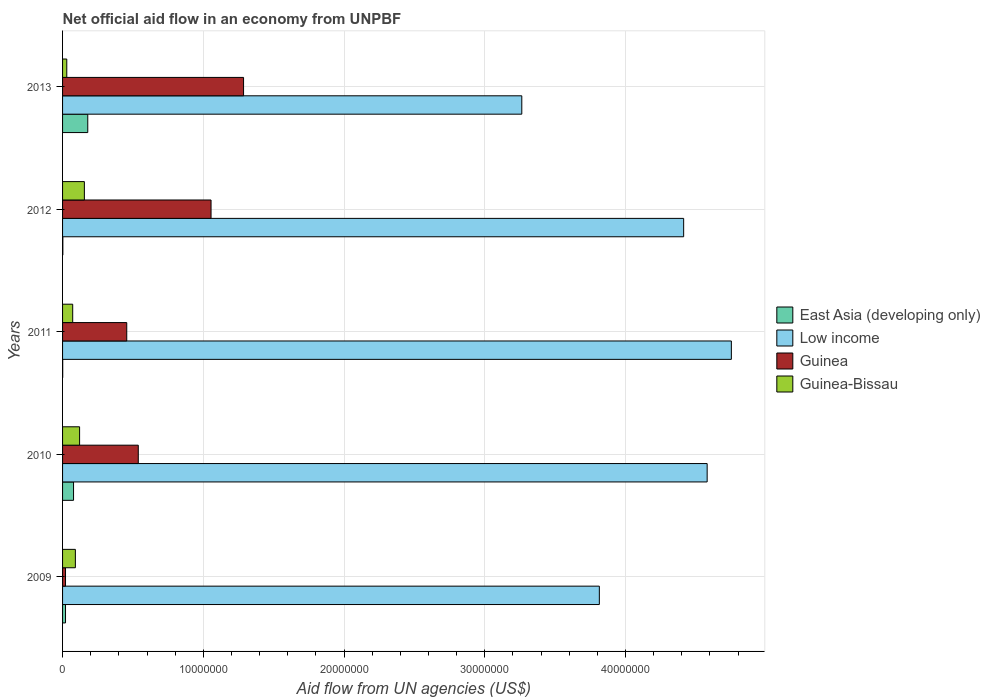How many bars are there on the 1st tick from the top?
Offer a terse response. 4. In how many cases, is the number of bars for a given year not equal to the number of legend labels?
Give a very brief answer. 0. What is the net official aid flow in East Asia (developing only) in 2010?
Offer a terse response. 7.80e+05. Across all years, what is the maximum net official aid flow in Low income?
Offer a terse response. 4.75e+07. Across all years, what is the minimum net official aid flow in Low income?
Offer a very short reply. 3.26e+07. In which year was the net official aid flow in Guinea minimum?
Your answer should be very brief. 2009. What is the total net official aid flow in East Asia (developing only) in the graph?
Offer a very short reply. 2.81e+06. What is the difference between the net official aid flow in Guinea-Bissau in 2011 and that in 2012?
Offer a very short reply. -8.30e+05. What is the difference between the net official aid flow in Low income in 2013 and the net official aid flow in Guinea-Bissau in 2012?
Give a very brief answer. 3.11e+07. What is the average net official aid flow in East Asia (developing only) per year?
Offer a very short reply. 5.62e+05. In the year 2012, what is the difference between the net official aid flow in East Asia (developing only) and net official aid flow in Guinea-Bissau?
Keep it short and to the point. -1.53e+06. In how many years, is the net official aid flow in Guinea-Bissau greater than 28000000 US$?
Your answer should be compact. 0. What is the ratio of the net official aid flow in East Asia (developing only) in 2012 to that in 2013?
Provide a succinct answer. 0.01. Is the net official aid flow in East Asia (developing only) in 2009 less than that in 2011?
Your answer should be compact. No. What is the difference between the highest and the second highest net official aid flow in Low income?
Give a very brief answer. 1.72e+06. What is the difference between the highest and the lowest net official aid flow in Guinea?
Offer a very short reply. 1.26e+07. What does the 4th bar from the top in 2013 represents?
Provide a succinct answer. East Asia (developing only). Are all the bars in the graph horizontal?
Your answer should be compact. Yes. How many years are there in the graph?
Offer a very short reply. 5. What is the difference between two consecutive major ticks on the X-axis?
Your answer should be very brief. 1.00e+07. How many legend labels are there?
Keep it short and to the point. 4. How are the legend labels stacked?
Offer a terse response. Vertical. What is the title of the graph?
Offer a very short reply. Net official aid flow in an economy from UNPBF. Does "Aruba" appear as one of the legend labels in the graph?
Offer a very short reply. No. What is the label or title of the X-axis?
Your response must be concise. Aid flow from UN agencies (US$). What is the label or title of the Y-axis?
Your answer should be compact. Years. What is the Aid flow from UN agencies (US$) in Low income in 2009?
Your response must be concise. 3.81e+07. What is the Aid flow from UN agencies (US$) of Guinea-Bissau in 2009?
Provide a short and direct response. 9.10e+05. What is the Aid flow from UN agencies (US$) of East Asia (developing only) in 2010?
Offer a very short reply. 7.80e+05. What is the Aid flow from UN agencies (US$) in Low income in 2010?
Provide a short and direct response. 4.58e+07. What is the Aid flow from UN agencies (US$) of Guinea in 2010?
Make the answer very short. 5.38e+06. What is the Aid flow from UN agencies (US$) of Guinea-Bissau in 2010?
Provide a short and direct response. 1.21e+06. What is the Aid flow from UN agencies (US$) of East Asia (developing only) in 2011?
Provide a short and direct response. 10000. What is the Aid flow from UN agencies (US$) of Low income in 2011?
Offer a terse response. 4.75e+07. What is the Aid flow from UN agencies (US$) in Guinea in 2011?
Keep it short and to the point. 4.56e+06. What is the Aid flow from UN agencies (US$) of Guinea-Bissau in 2011?
Provide a succinct answer. 7.20e+05. What is the Aid flow from UN agencies (US$) of East Asia (developing only) in 2012?
Your answer should be very brief. 2.00e+04. What is the Aid flow from UN agencies (US$) in Low income in 2012?
Provide a short and direct response. 4.41e+07. What is the Aid flow from UN agencies (US$) of Guinea in 2012?
Your answer should be compact. 1.06e+07. What is the Aid flow from UN agencies (US$) of Guinea-Bissau in 2012?
Make the answer very short. 1.55e+06. What is the Aid flow from UN agencies (US$) in East Asia (developing only) in 2013?
Provide a short and direct response. 1.79e+06. What is the Aid flow from UN agencies (US$) in Low income in 2013?
Provide a succinct answer. 3.26e+07. What is the Aid flow from UN agencies (US$) of Guinea in 2013?
Your answer should be compact. 1.29e+07. Across all years, what is the maximum Aid flow from UN agencies (US$) in East Asia (developing only)?
Your response must be concise. 1.79e+06. Across all years, what is the maximum Aid flow from UN agencies (US$) of Low income?
Your response must be concise. 4.75e+07. Across all years, what is the maximum Aid flow from UN agencies (US$) in Guinea?
Offer a terse response. 1.29e+07. Across all years, what is the maximum Aid flow from UN agencies (US$) in Guinea-Bissau?
Provide a short and direct response. 1.55e+06. Across all years, what is the minimum Aid flow from UN agencies (US$) of East Asia (developing only)?
Offer a very short reply. 10000. Across all years, what is the minimum Aid flow from UN agencies (US$) of Low income?
Offer a very short reply. 3.26e+07. Across all years, what is the minimum Aid flow from UN agencies (US$) in Guinea?
Keep it short and to the point. 2.10e+05. What is the total Aid flow from UN agencies (US$) in East Asia (developing only) in the graph?
Your response must be concise. 2.81e+06. What is the total Aid flow from UN agencies (US$) of Low income in the graph?
Your answer should be very brief. 2.08e+08. What is the total Aid flow from UN agencies (US$) in Guinea in the graph?
Your response must be concise. 3.36e+07. What is the total Aid flow from UN agencies (US$) in Guinea-Bissau in the graph?
Your answer should be compact. 4.69e+06. What is the difference between the Aid flow from UN agencies (US$) of East Asia (developing only) in 2009 and that in 2010?
Keep it short and to the point. -5.70e+05. What is the difference between the Aid flow from UN agencies (US$) in Low income in 2009 and that in 2010?
Your response must be concise. -7.66e+06. What is the difference between the Aid flow from UN agencies (US$) in Guinea in 2009 and that in 2010?
Your answer should be very brief. -5.17e+06. What is the difference between the Aid flow from UN agencies (US$) of Low income in 2009 and that in 2011?
Offer a very short reply. -9.38e+06. What is the difference between the Aid flow from UN agencies (US$) of Guinea in 2009 and that in 2011?
Give a very brief answer. -4.35e+06. What is the difference between the Aid flow from UN agencies (US$) of Guinea-Bissau in 2009 and that in 2011?
Offer a very short reply. 1.90e+05. What is the difference between the Aid flow from UN agencies (US$) in Low income in 2009 and that in 2012?
Offer a terse response. -5.99e+06. What is the difference between the Aid flow from UN agencies (US$) in Guinea in 2009 and that in 2012?
Make the answer very short. -1.03e+07. What is the difference between the Aid flow from UN agencies (US$) of Guinea-Bissau in 2009 and that in 2012?
Ensure brevity in your answer.  -6.40e+05. What is the difference between the Aid flow from UN agencies (US$) in East Asia (developing only) in 2009 and that in 2013?
Your answer should be compact. -1.58e+06. What is the difference between the Aid flow from UN agencies (US$) in Low income in 2009 and that in 2013?
Offer a very short reply. 5.51e+06. What is the difference between the Aid flow from UN agencies (US$) in Guinea in 2009 and that in 2013?
Keep it short and to the point. -1.26e+07. What is the difference between the Aid flow from UN agencies (US$) in Guinea-Bissau in 2009 and that in 2013?
Your response must be concise. 6.10e+05. What is the difference between the Aid flow from UN agencies (US$) in East Asia (developing only) in 2010 and that in 2011?
Your answer should be compact. 7.70e+05. What is the difference between the Aid flow from UN agencies (US$) of Low income in 2010 and that in 2011?
Give a very brief answer. -1.72e+06. What is the difference between the Aid flow from UN agencies (US$) of Guinea in 2010 and that in 2011?
Give a very brief answer. 8.20e+05. What is the difference between the Aid flow from UN agencies (US$) in Guinea-Bissau in 2010 and that in 2011?
Give a very brief answer. 4.90e+05. What is the difference between the Aid flow from UN agencies (US$) in East Asia (developing only) in 2010 and that in 2012?
Your response must be concise. 7.60e+05. What is the difference between the Aid flow from UN agencies (US$) in Low income in 2010 and that in 2012?
Your answer should be compact. 1.67e+06. What is the difference between the Aid flow from UN agencies (US$) of Guinea in 2010 and that in 2012?
Give a very brief answer. -5.17e+06. What is the difference between the Aid flow from UN agencies (US$) of Guinea-Bissau in 2010 and that in 2012?
Provide a short and direct response. -3.40e+05. What is the difference between the Aid flow from UN agencies (US$) of East Asia (developing only) in 2010 and that in 2013?
Make the answer very short. -1.01e+06. What is the difference between the Aid flow from UN agencies (US$) of Low income in 2010 and that in 2013?
Keep it short and to the point. 1.32e+07. What is the difference between the Aid flow from UN agencies (US$) in Guinea in 2010 and that in 2013?
Provide a short and direct response. -7.48e+06. What is the difference between the Aid flow from UN agencies (US$) in Guinea-Bissau in 2010 and that in 2013?
Give a very brief answer. 9.10e+05. What is the difference between the Aid flow from UN agencies (US$) of Low income in 2011 and that in 2012?
Your answer should be compact. 3.39e+06. What is the difference between the Aid flow from UN agencies (US$) in Guinea in 2011 and that in 2012?
Keep it short and to the point. -5.99e+06. What is the difference between the Aid flow from UN agencies (US$) in Guinea-Bissau in 2011 and that in 2012?
Your response must be concise. -8.30e+05. What is the difference between the Aid flow from UN agencies (US$) of East Asia (developing only) in 2011 and that in 2013?
Your answer should be compact. -1.78e+06. What is the difference between the Aid flow from UN agencies (US$) of Low income in 2011 and that in 2013?
Make the answer very short. 1.49e+07. What is the difference between the Aid flow from UN agencies (US$) in Guinea in 2011 and that in 2013?
Provide a short and direct response. -8.30e+06. What is the difference between the Aid flow from UN agencies (US$) of Guinea-Bissau in 2011 and that in 2013?
Offer a terse response. 4.20e+05. What is the difference between the Aid flow from UN agencies (US$) in East Asia (developing only) in 2012 and that in 2013?
Give a very brief answer. -1.77e+06. What is the difference between the Aid flow from UN agencies (US$) of Low income in 2012 and that in 2013?
Ensure brevity in your answer.  1.15e+07. What is the difference between the Aid flow from UN agencies (US$) of Guinea in 2012 and that in 2013?
Give a very brief answer. -2.31e+06. What is the difference between the Aid flow from UN agencies (US$) in Guinea-Bissau in 2012 and that in 2013?
Your answer should be very brief. 1.25e+06. What is the difference between the Aid flow from UN agencies (US$) in East Asia (developing only) in 2009 and the Aid flow from UN agencies (US$) in Low income in 2010?
Your answer should be very brief. -4.56e+07. What is the difference between the Aid flow from UN agencies (US$) in East Asia (developing only) in 2009 and the Aid flow from UN agencies (US$) in Guinea in 2010?
Keep it short and to the point. -5.17e+06. What is the difference between the Aid flow from UN agencies (US$) of East Asia (developing only) in 2009 and the Aid flow from UN agencies (US$) of Guinea-Bissau in 2010?
Make the answer very short. -1.00e+06. What is the difference between the Aid flow from UN agencies (US$) of Low income in 2009 and the Aid flow from UN agencies (US$) of Guinea in 2010?
Give a very brief answer. 3.28e+07. What is the difference between the Aid flow from UN agencies (US$) in Low income in 2009 and the Aid flow from UN agencies (US$) in Guinea-Bissau in 2010?
Your response must be concise. 3.69e+07. What is the difference between the Aid flow from UN agencies (US$) of Guinea in 2009 and the Aid flow from UN agencies (US$) of Guinea-Bissau in 2010?
Give a very brief answer. -1.00e+06. What is the difference between the Aid flow from UN agencies (US$) of East Asia (developing only) in 2009 and the Aid flow from UN agencies (US$) of Low income in 2011?
Keep it short and to the point. -4.73e+07. What is the difference between the Aid flow from UN agencies (US$) of East Asia (developing only) in 2009 and the Aid flow from UN agencies (US$) of Guinea in 2011?
Offer a very short reply. -4.35e+06. What is the difference between the Aid flow from UN agencies (US$) of East Asia (developing only) in 2009 and the Aid flow from UN agencies (US$) of Guinea-Bissau in 2011?
Your response must be concise. -5.10e+05. What is the difference between the Aid flow from UN agencies (US$) of Low income in 2009 and the Aid flow from UN agencies (US$) of Guinea in 2011?
Ensure brevity in your answer.  3.36e+07. What is the difference between the Aid flow from UN agencies (US$) of Low income in 2009 and the Aid flow from UN agencies (US$) of Guinea-Bissau in 2011?
Provide a short and direct response. 3.74e+07. What is the difference between the Aid flow from UN agencies (US$) in Guinea in 2009 and the Aid flow from UN agencies (US$) in Guinea-Bissau in 2011?
Make the answer very short. -5.10e+05. What is the difference between the Aid flow from UN agencies (US$) of East Asia (developing only) in 2009 and the Aid flow from UN agencies (US$) of Low income in 2012?
Make the answer very short. -4.39e+07. What is the difference between the Aid flow from UN agencies (US$) in East Asia (developing only) in 2009 and the Aid flow from UN agencies (US$) in Guinea in 2012?
Your answer should be very brief. -1.03e+07. What is the difference between the Aid flow from UN agencies (US$) of East Asia (developing only) in 2009 and the Aid flow from UN agencies (US$) of Guinea-Bissau in 2012?
Make the answer very short. -1.34e+06. What is the difference between the Aid flow from UN agencies (US$) of Low income in 2009 and the Aid flow from UN agencies (US$) of Guinea in 2012?
Your response must be concise. 2.76e+07. What is the difference between the Aid flow from UN agencies (US$) in Low income in 2009 and the Aid flow from UN agencies (US$) in Guinea-Bissau in 2012?
Your answer should be compact. 3.66e+07. What is the difference between the Aid flow from UN agencies (US$) in Guinea in 2009 and the Aid flow from UN agencies (US$) in Guinea-Bissau in 2012?
Provide a succinct answer. -1.34e+06. What is the difference between the Aid flow from UN agencies (US$) in East Asia (developing only) in 2009 and the Aid flow from UN agencies (US$) in Low income in 2013?
Your response must be concise. -3.24e+07. What is the difference between the Aid flow from UN agencies (US$) of East Asia (developing only) in 2009 and the Aid flow from UN agencies (US$) of Guinea in 2013?
Ensure brevity in your answer.  -1.26e+07. What is the difference between the Aid flow from UN agencies (US$) in East Asia (developing only) in 2009 and the Aid flow from UN agencies (US$) in Guinea-Bissau in 2013?
Your answer should be very brief. -9.00e+04. What is the difference between the Aid flow from UN agencies (US$) in Low income in 2009 and the Aid flow from UN agencies (US$) in Guinea in 2013?
Your answer should be very brief. 2.53e+07. What is the difference between the Aid flow from UN agencies (US$) in Low income in 2009 and the Aid flow from UN agencies (US$) in Guinea-Bissau in 2013?
Keep it short and to the point. 3.78e+07. What is the difference between the Aid flow from UN agencies (US$) of East Asia (developing only) in 2010 and the Aid flow from UN agencies (US$) of Low income in 2011?
Give a very brief answer. -4.67e+07. What is the difference between the Aid flow from UN agencies (US$) in East Asia (developing only) in 2010 and the Aid flow from UN agencies (US$) in Guinea in 2011?
Your response must be concise. -3.78e+06. What is the difference between the Aid flow from UN agencies (US$) of Low income in 2010 and the Aid flow from UN agencies (US$) of Guinea in 2011?
Offer a very short reply. 4.12e+07. What is the difference between the Aid flow from UN agencies (US$) in Low income in 2010 and the Aid flow from UN agencies (US$) in Guinea-Bissau in 2011?
Make the answer very short. 4.51e+07. What is the difference between the Aid flow from UN agencies (US$) of Guinea in 2010 and the Aid flow from UN agencies (US$) of Guinea-Bissau in 2011?
Keep it short and to the point. 4.66e+06. What is the difference between the Aid flow from UN agencies (US$) of East Asia (developing only) in 2010 and the Aid flow from UN agencies (US$) of Low income in 2012?
Your answer should be compact. -4.34e+07. What is the difference between the Aid flow from UN agencies (US$) of East Asia (developing only) in 2010 and the Aid flow from UN agencies (US$) of Guinea in 2012?
Make the answer very short. -9.77e+06. What is the difference between the Aid flow from UN agencies (US$) of East Asia (developing only) in 2010 and the Aid flow from UN agencies (US$) of Guinea-Bissau in 2012?
Provide a short and direct response. -7.70e+05. What is the difference between the Aid flow from UN agencies (US$) in Low income in 2010 and the Aid flow from UN agencies (US$) in Guinea in 2012?
Your response must be concise. 3.52e+07. What is the difference between the Aid flow from UN agencies (US$) of Low income in 2010 and the Aid flow from UN agencies (US$) of Guinea-Bissau in 2012?
Your response must be concise. 4.42e+07. What is the difference between the Aid flow from UN agencies (US$) of Guinea in 2010 and the Aid flow from UN agencies (US$) of Guinea-Bissau in 2012?
Provide a succinct answer. 3.83e+06. What is the difference between the Aid flow from UN agencies (US$) in East Asia (developing only) in 2010 and the Aid flow from UN agencies (US$) in Low income in 2013?
Keep it short and to the point. -3.18e+07. What is the difference between the Aid flow from UN agencies (US$) in East Asia (developing only) in 2010 and the Aid flow from UN agencies (US$) in Guinea in 2013?
Offer a terse response. -1.21e+07. What is the difference between the Aid flow from UN agencies (US$) of Low income in 2010 and the Aid flow from UN agencies (US$) of Guinea in 2013?
Offer a very short reply. 3.29e+07. What is the difference between the Aid flow from UN agencies (US$) of Low income in 2010 and the Aid flow from UN agencies (US$) of Guinea-Bissau in 2013?
Your response must be concise. 4.55e+07. What is the difference between the Aid flow from UN agencies (US$) in Guinea in 2010 and the Aid flow from UN agencies (US$) in Guinea-Bissau in 2013?
Offer a very short reply. 5.08e+06. What is the difference between the Aid flow from UN agencies (US$) of East Asia (developing only) in 2011 and the Aid flow from UN agencies (US$) of Low income in 2012?
Make the answer very short. -4.41e+07. What is the difference between the Aid flow from UN agencies (US$) of East Asia (developing only) in 2011 and the Aid flow from UN agencies (US$) of Guinea in 2012?
Provide a succinct answer. -1.05e+07. What is the difference between the Aid flow from UN agencies (US$) of East Asia (developing only) in 2011 and the Aid flow from UN agencies (US$) of Guinea-Bissau in 2012?
Make the answer very short. -1.54e+06. What is the difference between the Aid flow from UN agencies (US$) of Low income in 2011 and the Aid flow from UN agencies (US$) of Guinea in 2012?
Your answer should be very brief. 3.70e+07. What is the difference between the Aid flow from UN agencies (US$) of Low income in 2011 and the Aid flow from UN agencies (US$) of Guinea-Bissau in 2012?
Keep it short and to the point. 4.60e+07. What is the difference between the Aid flow from UN agencies (US$) in Guinea in 2011 and the Aid flow from UN agencies (US$) in Guinea-Bissau in 2012?
Ensure brevity in your answer.  3.01e+06. What is the difference between the Aid flow from UN agencies (US$) of East Asia (developing only) in 2011 and the Aid flow from UN agencies (US$) of Low income in 2013?
Offer a terse response. -3.26e+07. What is the difference between the Aid flow from UN agencies (US$) of East Asia (developing only) in 2011 and the Aid flow from UN agencies (US$) of Guinea in 2013?
Your answer should be compact. -1.28e+07. What is the difference between the Aid flow from UN agencies (US$) in Low income in 2011 and the Aid flow from UN agencies (US$) in Guinea in 2013?
Give a very brief answer. 3.47e+07. What is the difference between the Aid flow from UN agencies (US$) in Low income in 2011 and the Aid flow from UN agencies (US$) in Guinea-Bissau in 2013?
Offer a very short reply. 4.72e+07. What is the difference between the Aid flow from UN agencies (US$) in Guinea in 2011 and the Aid flow from UN agencies (US$) in Guinea-Bissau in 2013?
Offer a very short reply. 4.26e+06. What is the difference between the Aid flow from UN agencies (US$) in East Asia (developing only) in 2012 and the Aid flow from UN agencies (US$) in Low income in 2013?
Your answer should be very brief. -3.26e+07. What is the difference between the Aid flow from UN agencies (US$) of East Asia (developing only) in 2012 and the Aid flow from UN agencies (US$) of Guinea in 2013?
Your answer should be compact. -1.28e+07. What is the difference between the Aid flow from UN agencies (US$) in East Asia (developing only) in 2012 and the Aid flow from UN agencies (US$) in Guinea-Bissau in 2013?
Your answer should be compact. -2.80e+05. What is the difference between the Aid flow from UN agencies (US$) of Low income in 2012 and the Aid flow from UN agencies (US$) of Guinea in 2013?
Provide a short and direct response. 3.13e+07. What is the difference between the Aid flow from UN agencies (US$) in Low income in 2012 and the Aid flow from UN agencies (US$) in Guinea-Bissau in 2013?
Your response must be concise. 4.38e+07. What is the difference between the Aid flow from UN agencies (US$) in Guinea in 2012 and the Aid flow from UN agencies (US$) in Guinea-Bissau in 2013?
Ensure brevity in your answer.  1.02e+07. What is the average Aid flow from UN agencies (US$) in East Asia (developing only) per year?
Your answer should be very brief. 5.62e+05. What is the average Aid flow from UN agencies (US$) in Low income per year?
Provide a succinct answer. 4.16e+07. What is the average Aid flow from UN agencies (US$) of Guinea per year?
Provide a succinct answer. 6.71e+06. What is the average Aid flow from UN agencies (US$) of Guinea-Bissau per year?
Give a very brief answer. 9.38e+05. In the year 2009, what is the difference between the Aid flow from UN agencies (US$) of East Asia (developing only) and Aid flow from UN agencies (US$) of Low income?
Offer a very short reply. -3.79e+07. In the year 2009, what is the difference between the Aid flow from UN agencies (US$) in East Asia (developing only) and Aid flow from UN agencies (US$) in Guinea?
Your answer should be very brief. 0. In the year 2009, what is the difference between the Aid flow from UN agencies (US$) in East Asia (developing only) and Aid flow from UN agencies (US$) in Guinea-Bissau?
Make the answer very short. -7.00e+05. In the year 2009, what is the difference between the Aid flow from UN agencies (US$) in Low income and Aid flow from UN agencies (US$) in Guinea?
Provide a short and direct response. 3.79e+07. In the year 2009, what is the difference between the Aid flow from UN agencies (US$) in Low income and Aid flow from UN agencies (US$) in Guinea-Bissau?
Your answer should be very brief. 3.72e+07. In the year 2009, what is the difference between the Aid flow from UN agencies (US$) in Guinea and Aid flow from UN agencies (US$) in Guinea-Bissau?
Your response must be concise. -7.00e+05. In the year 2010, what is the difference between the Aid flow from UN agencies (US$) in East Asia (developing only) and Aid flow from UN agencies (US$) in Low income?
Provide a succinct answer. -4.50e+07. In the year 2010, what is the difference between the Aid flow from UN agencies (US$) in East Asia (developing only) and Aid flow from UN agencies (US$) in Guinea?
Your response must be concise. -4.60e+06. In the year 2010, what is the difference between the Aid flow from UN agencies (US$) in East Asia (developing only) and Aid flow from UN agencies (US$) in Guinea-Bissau?
Provide a short and direct response. -4.30e+05. In the year 2010, what is the difference between the Aid flow from UN agencies (US$) in Low income and Aid flow from UN agencies (US$) in Guinea?
Provide a short and direct response. 4.04e+07. In the year 2010, what is the difference between the Aid flow from UN agencies (US$) in Low income and Aid flow from UN agencies (US$) in Guinea-Bissau?
Your response must be concise. 4.46e+07. In the year 2010, what is the difference between the Aid flow from UN agencies (US$) of Guinea and Aid flow from UN agencies (US$) of Guinea-Bissau?
Offer a terse response. 4.17e+06. In the year 2011, what is the difference between the Aid flow from UN agencies (US$) of East Asia (developing only) and Aid flow from UN agencies (US$) of Low income?
Ensure brevity in your answer.  -4.75e+07. In the year 2011, what is the difference between the Aid flow from UN agencies (US$) of East Asia (developing only) and Aid flow from UN agencies (US$) of Guinea?
Keep it short and to the point. -4.55e+06. In the year 2011, what is the difference between the Aid flow from UN agencies (US$) of East Asia (developing only) and Aid flow from UN agencies (US$) of Guinea-Bissau?
Provide a succinct answer. -7.10e+05. In the year 2011, what is the difference between the Aid flow from UN agencies (US$) of Low income and Aid flow from UN agencies (US$) of Guinea?
Offer a terse response. 4.30e+07. In the year 2011, what is the difference between the Aid flow from UN agencies (US$) in Low income and Aid flow from UN agencies (US$) in Guinea-Bissau?
Ensure brevity in your answer.  4.68e+07. In the year 2011, what is the difference between the Aid flow from UN agencies (US$) of Guinea and Aid flow from UN agencies (US$) of Guinea-Bissau?
Keep it short and to the point. 3.84e+06. In the year 2012, what is the difference between the Aid flow from UN agencies (US$) of East Asia (developing only) and Aid flow from UN agencies (US$) of Low income?
Offer a terse response. -4.41e+07. In the year 2012, what is the difference between the Aid flow from UN agencies (US$) in East Asia (developing only) and Aid flow from UN agencies (US$) in Guinea?
Provide a succinct answer. -1.05e+07. In the year 2012, what is the difference between the Aid flow from UN agencies (US$) in East Asia (developing only) and Aid flow from UN agencies (US$) in Guinea-Bissau?
Provide a short and direct response. -1.53e+06. In the year 2012, what is the difference between the Aid flow from UN agencies (US$) in Low income and Aid flow from UN agencies (US$) in Guinea?
Your answer should be very brief. 3.36e+07. In the year 2012, what is the difference between the Aid flow from UN agencies (US$) of Low income and Aid flow from UN agencies (US$) of Guinea-Bissau?
Keep it short and to the point. 4.26e+07. In the year 2012, what is the difference between the Aid flow from UN agencies (US$) of Guinea and Aid flow from UN agencies (US$) of Guinea-Bissau?
Your answer should be very brief. 9.00e+06. In the year 2013, what is the difference between the Aid flow from UN agencies (US$) of East Asia (developing only) and Aid flow from UN agencies (US$) of Low income?
Your answer should be compact. -3.08e+07. In the year 2013, what is the difference between the Aid flow from UN agencies (US$) of East Asia (developing only) and Aid flow from UN agencies (US$) of Guinea?
Your response must be concise. -1.11e+07. In the year 2013, what is the difference between the Aid flow from UN agencies (US$) in East Asia (developing only) and Aid flow from UN agencies (US$) in Guinea-Bissau?
Your response must be concise. 1.49e+06. In the year 2013, what is the difference between the Aid flow from UN agencies (US$) of Low income and Aid flow from UN agencies (US$) of Guinea?
Provide a succinct answer. 1.98e+07. In the year 2013, what is the difference between the Aid flow from UN agencies (US$) in Low income and Aid flow from UN agencies (US$) in Guinea-Bissau?
Your answer should be very brief. 3.23e+07. In the year 2013, what is the difference between the Aid flow from UN agencies (US$) of Guinea and Aid flow from UN agencies (US$) of Guinea-Bissau?
Keep it short and to the point. 1.26e+07. What is the ratio of the Aid flow from UN agencies (US$) of East Asia (developing only) in 2009 to that in 2010?
Offer a terse response. 0.27. What is the ratio of the Aid flow from UN agencies (US$) of Low income in 2009 to that in 2010?
Ensure brevity in your answer.  0.83. What is the ratio of the Aid flow from UN agencies (US$) of Guinea in 2009 to that in 2010?
Ensure brevity in your answer.  0.04. What is the ratio of the Aid flow from UN agencies (US$) of Guinea-Bissau in 2009 to that in 2010?
Offer a very short reply. 0.75. What is the ratio of the Aid flow from UN agencies (US$) of Low income in 2009 to that in 2011?
Provide a short and direct response. 0.8. What is the ratio of the Aid flow from UN agencies (US$) in Guinea in 2009 to that in 2011?
Your response must be concise. 0.05. What is the ratio of the Aid flow from UN agencies (US$) of Guinea-Bissau in 2009 to that in 2011?
Ensure brevity in your answer.  1.26. What is the ratio of the Aid flow from UN agencies (US$) in East Asia (developing only) in 2009 to that in 2012?
Offer a very short reply. 10.5. What is the ratio of the Aid flow from UN agencies (US$) of Low income in 2009 to that in 2012?
Offer a terse response. 0.86. What is the ratio of the Aid flow from UN agencies (US$) in Guinea in 2009 to that in 2012?
Make the answer very short. 0.02. What is the ratio of the Aid flow from UN agencies (US$) of Guinea-Bissau in 2009 to that in 2012?
Ensure brevity in your answer.  0.59. What is the ratio of the Aid flow from UN agencies (US$) in East Asia (developing only) in 2009 to that in 2013?
Your answer should be compact. 0.12. What is the ratio of the Aid flow from UN agencies (US$) in Low income in 2009 to that in 2013?
Provide a short and direct response. 1.17. What is the ratio of the Aid flow from UN agencies (US$) in Guinea in 2009 to that in 2013?
Your answer should be compact. 0.02. What is the ratio of the Aid flow from UN agencies (US$) of Guinea-Bissau in 2009 to that in 2013?
Keep it short and to the point. 3.03. What is the ratio of the Aid flow from UN agencies (US$) of Low income in 2010 to that in 2011?
Keep it short and to the point. 0.96. What is the ratio of the Aid flow from UN agencies (US$) of Guinea in 2010 to that in 2011?
Your answer should be very brief. 1.18. What is the ratio of the Aid flow from UN agencies (US$) in Guinea-Bissau in 2010 to that in 2011?
Offer a terse response. 1.68. What is the ratio of the Aid flow from UN agencies (US$) in Low income in 2010 to that in 2012?
Make the answer very short. 1.04. What is the ratio of the Aid flow from UN agencies (US$) in Guinea in 2010 to that in 2012?
Make the answer very short. 0.51. What is the ratio of the Aid flow from UN agencies (US$) of Guinea-Bissau in 2010 to that in 2012?
Offer a very short reply. 0.78. What is the ratio of the Aid flow from UN agencies (US$) in East Asia (developing only) in 2010 to that in 2013?
Offer a very short reply. 0.44. What is the ratio of the Aid flow from UN agencies (US$) of Low income in 2010 to that in 2013?
Make the answer very short. 1.4. What is the ratio of the Aid flow from UN agencies (US$) in Guinea in 2010 to that in 2013?
Your answer should be compact. 0.42. What is the ratio of the Aid flow from UN agencies (US$) of Guinea-Bissau in 2010 to that in 2013?
Make the answer very short. 4.03. What is the ratio of the Aid flow from UN agencies (US$) in East Asia (developing only) in 2011 to that in 2012?
Provide a succinct answer. 0.5. What is the ratio of the Aid flow from UN agencies (US$) of Low income in 2011 to that in 2012?
Provide a succinct answer. 1.08. What is the ratio of the Aid flow from UN agencies (US$) of Guinea in 2011 to that in 2012?
Offer a very short reply. 0.43. What is the ratio of the Aid flow from UN agencies (US$) of Guinea-Bissau in 2011 to that in 2012?
Your answer should be compact. 0.46. What is the ratio of the Aid flow from UN agencies (US$) in East Asia (developing only) in 2011 to that in 2013?
Make the answer very short. 0.01. What is the ratio of the Aid flow from UN agencies (US$) in Low income in 2011 to that in 2013?
Give a very brief answer. 1.46. What is the ratio of the Aid flow from UN agencies (US$) in Guinea in 2011 to that in 2013?
Ensure brevity in your answer.  0.35. What is the ratio of the Aid flow from UN agencies (US$) of Guinea-Bissau in 2011 to that in 2013?
Your response must be concise. 2.4. What is the ratio of the Aid flow from UN agencies (US$) in East Asia (developing only) in 2012 to that in 2013?
Provide a succinct answer. 0.01. What is the ratio of the Aid flow from UN agencies (US$) in Low income in 2012 to that in 2013?
Keep it short and to the point. 1.35. What is the ratio of the Aid flow from UN agencies (US$) in Guinea in 2012 to that in 2013?
Offer a very short reply. 0.82. What is the ratio of the Aid flow from UN agencies (US$) in Guinea-Bissau in 2012 to that in 2013?
Offer a very short reply. 5.17. What is the difference between the highest and the second highest Aid flow from UN agencies (US$) of East Asia (developing only)?
Keep it short and to the point. 1.01e+06. What is the difference between the highest and the second highest Aid flow from UN agencies (US$) in Low income?
Your response must be concise. 1.72e+06. What is the difference between the highest and the second highest Aid flow from UN agencies (US$) of Guinea?
Provide a succinct answer. 2.31e+06. What is the difference between the highest and the lowest Aid flow from UN agencies (US$) of East Asia (developing only)?
Make the answer very short. 1.78e+06. What is the difference between the highest and the lowest Aid flow from UN agencies (US$) of Low income?
Offer a very short reply. 1.49e+07. What is the difference between the highest and the lowest Aid flow from UN agencies (US$) of Guinea?
Your response must be concise. 1.26e+07. What is the difference between the highest and the lowest Aid flow from UN agencies (US$) of Guinea-Bissau?
Your answer should be very brief. 1.25e+06. 